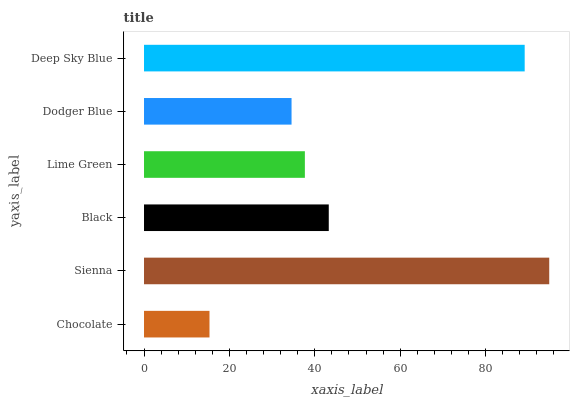Is Chocolate the minimum?
Answer yes or no. Yes. Is Sienna the maximum?
Answer yes or no. Yes. Is Black the minimum?
Answer yes or no. No. Is Black the maximum?
Answer yes or no. No. Is Sienna greater than Black?
Answer yes or no. Yes. Is Black less than Sienna?
Answer yes or no. Yes. Is Black greater than Sienna?
Answer yes or no. No. Is Sienna less than Black?
Answer yes or no. No. Is Black the high median?
Answer yes or no. Yes. Is Lime Green the low median?
Answer yes or no. Yes. Is Lime Green the high median?
Answer yes or no. No. Is Black the low median?
Answer yes or no. No. 